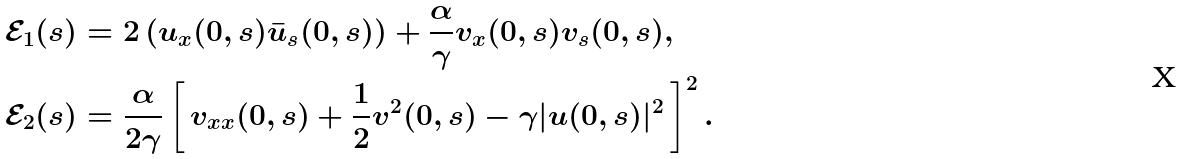<formula> <loc_0><loc_0><loc_500><loc_500>& \mathcal { E } _ { 1 } ( s ) = 2 \, ( u _ { x } ( 0 , s ) \bar { u } _ { s } ( 0 , s ) ) + \frac { \alpha } { \gamma } v _ { x } ( 0 , s ) v _ { s } ( 0 , s ) , \\ & \mathcal { E } _ { 2 } ( s ) = \frac { \alpha } { 2 \gamma } \left [ \, v _ { x x } ( 0 , s ) + \frac { 1 } { 2 } v ^ { 2 } ( 0 , s ) - \gamma | u ( 0 , s ) | ^ { 2 } \, \right ] ^ { 2 } .</formula> 